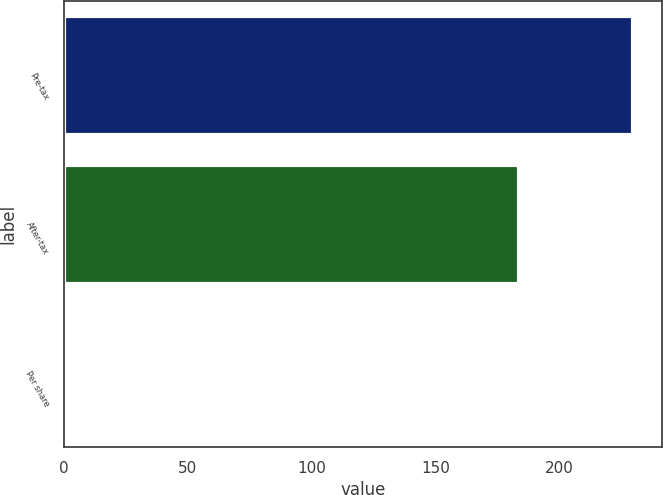Convert chart to OTSL. <chart><loc_0><loc_0><loc_500><loc_500><bar_chart><fcel>Pre-tax<fcel>After-tax<fcel>Per share<nl><fcel>230<fcel>184<fcel>0.12<nl></chart> 